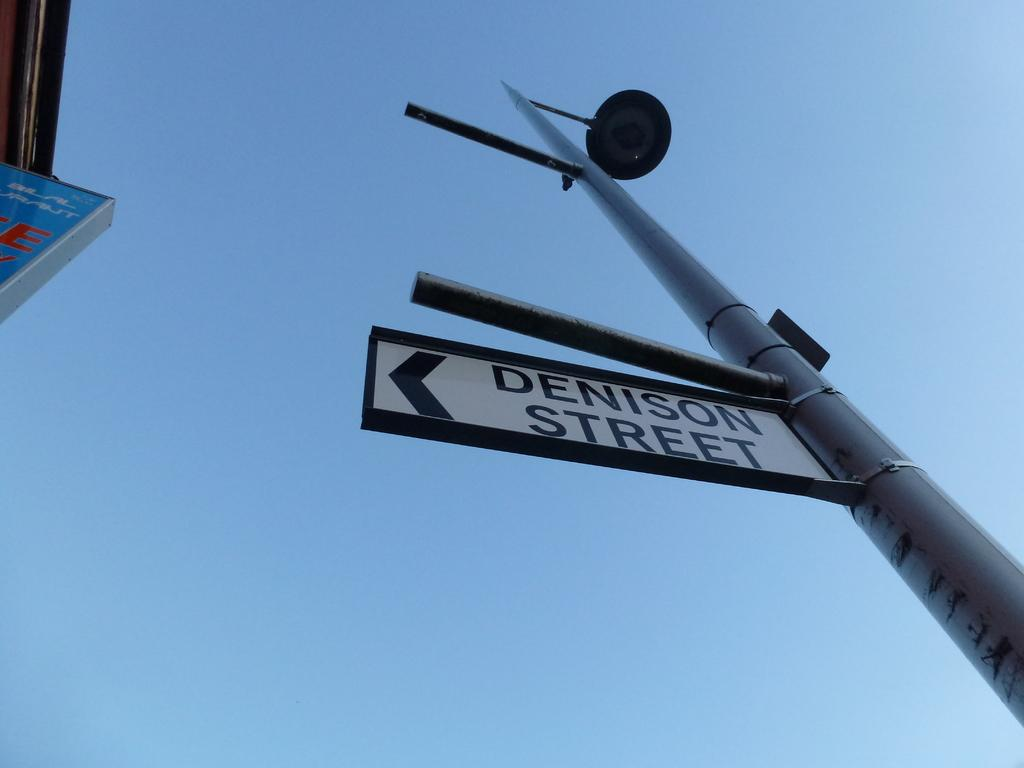<image>
Summarize the visual content of the image. Street sign on a pole that says Denison Street. 